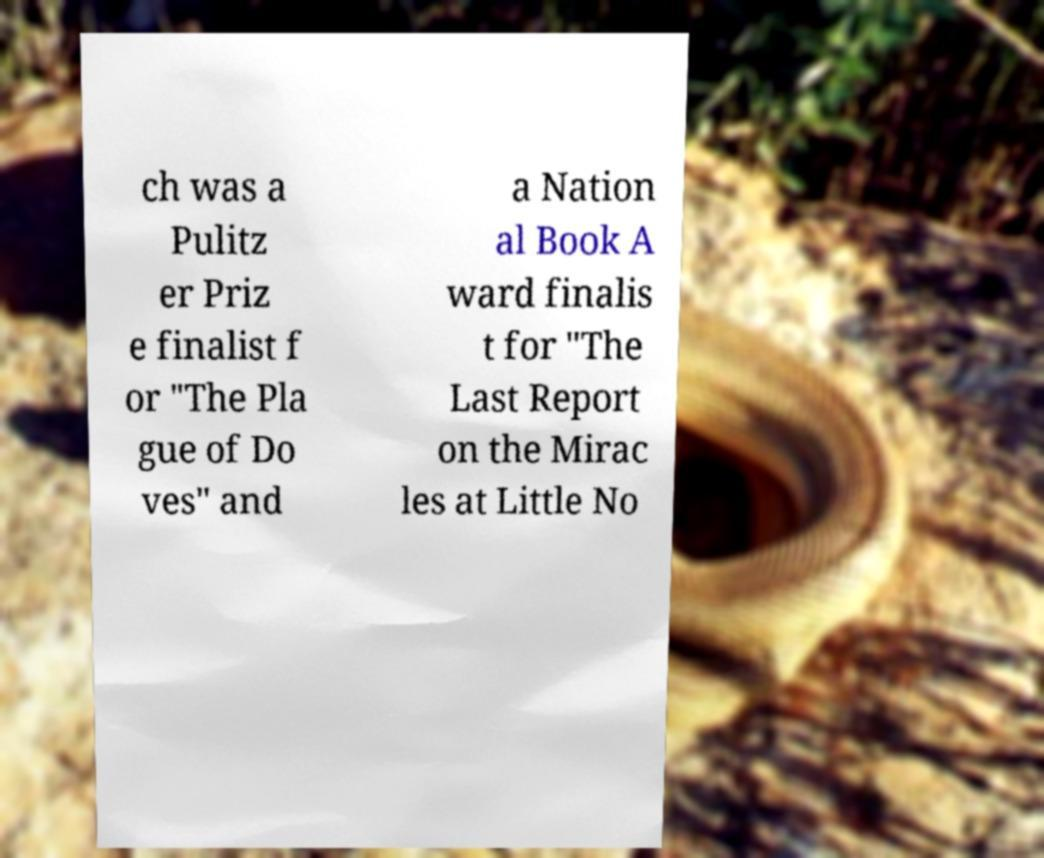Can you read and provide the text displayed in the image?This photo seems to have some interesting text. Can you extract and type it out for me? ch was a Pulitz er Priz e finalist f or "The Pla gue of Do ves" and a Nation al Book A ward finalis t for "The Last Report on the Mirac les at Little No 